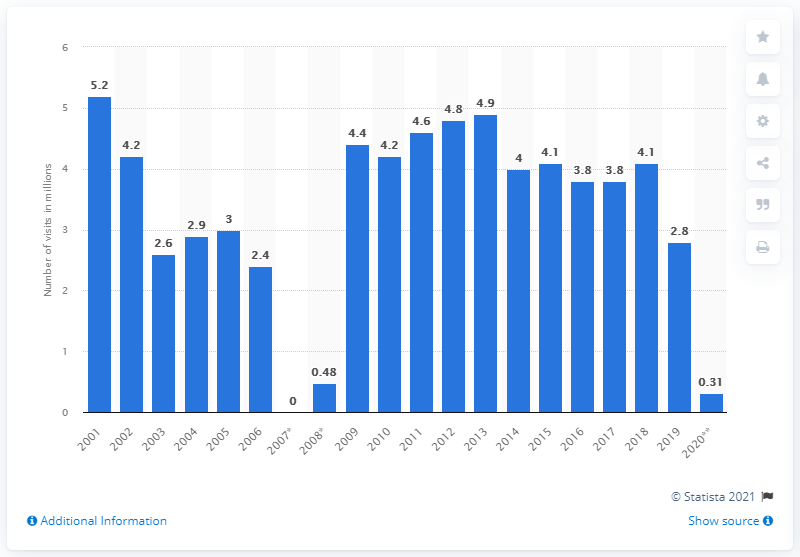Mention a couple of crucial points in this snapshot. The Smithsonian National Museum of American History received approximately 0.31 million visits in 2020. 